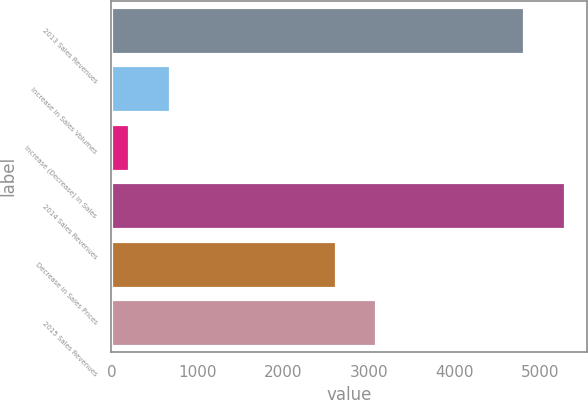<chart> <loc_0><loc_0><loc_500><loc_500><bar_chart><fcel>2013 Sales Revenues<fcel>Increase in Sales Volumes<fcel>Increase (Decrease) in Sales<fcel>2014 Sales Revenues<fcel>Decrease in Sales Prices<fcel>2015 Sales Revenues<nl><fcel>4809<fcel>681.2<fcel>209<fcel>5281.2<fcel>2616<fcel>3088.2<nl></chart> 